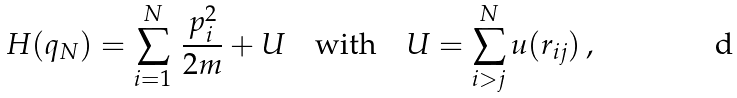Convert formula to latex. <formula><loc_0><loc_0><loc_500><loc_500>H ( q _ { N } ) = \sum _ { i = 1 } ^ { N } \, \frac { p _ { i } ^ { 2 } } { 2 m } + U \quad \text {with} \quad U = \sum _ { i > j } ^ { N } u ( r _ { i j } ) \, ,</formula> 